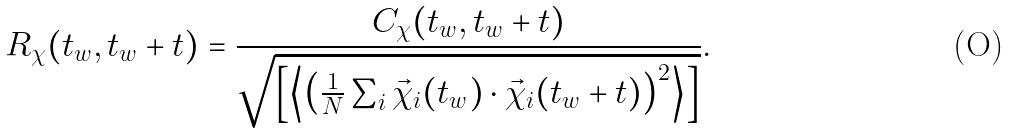Convert formula to latex. <formula><loc_0><loc_0><loc_500><loc_500>R _ { \chi } ( t _ { w } , t _ { w } + t ) = \frac { C _ { \chi } ( t _ { w } , t _ { w } + t ) } { \sqrt { \left [ \left \langle \left ( \frac { 1 } { N } \sum _ { i } \vec { \chi } _ { i } ( t _ { w } ) \cdot \vec { \chi } _ { i } ( t _ { w } + t ) \right ) ^ { 2 } \right \rangle \right ] } } .</formula> 